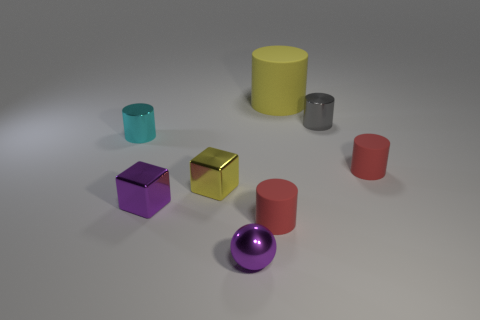Subtract 1 cylinders. How many cylinders are left? 4 Subtract all blue cylinders. Subtract all brown balls. How many cylinders are left? 5 Subtract all cylinders. How many objects are left? 3 Subtract all small yellow rubber cylinders. Subtract all yellow blocks. How many objects are left? 7 Add 8 yellow metallic cubes. How many yellow metallic cubes are left? 9 Add 7 small brown matte cylinders. How many small brown matte cylinders exist? 7 Subtract 1 yellow cylinders. How many objects are left? 7 